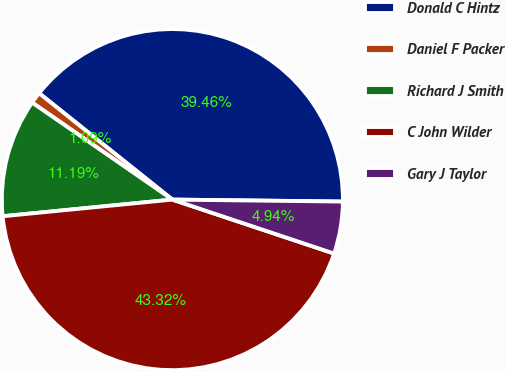Convert chart to OTSL. <chart><loc_0><loc_0><loc_500><loc_500><pie_chart><fcel>Donald C Hintz<fcel>Daniel F Packer<fcel>Richard J Smith<fcel>C John Wilder<fcel>Gary J Taylor<nl><fcel>39.46%<fcel>1.09%<fcel>11.19%<fcel>43.32%<fcel>4.94%<nl></chart> 